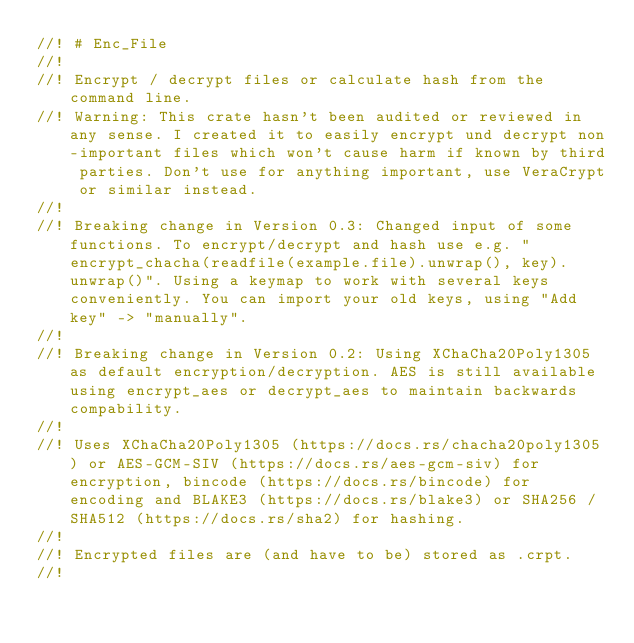Convert code to text. <code><loc_0><loc_0><loc_500><loc_500><_Rust_>//! # Enc_File
//!
//! Encrypt / decrypt files or calculate hash from the command line.
//! Warning: This crate hasn't been audited or reviewed in any sense. I created it to easily encrypt und decrypt non-important files which won't cause harm if known by third parties. Don't use for anything important, use VeraCrypt or similar instead.
//!
//! Breaking change in Version 0.3: Changed input of some functions. To encrypt/decrypt and hash use e.g. "encrypt_chacha(readfile(example.file).unwrap(), key).unwrap()". Using a keymap to work with several keys conveniently. You can import your old keys, using "Add key" -> "manually".
//!
//! Breaking change in Version 0.2: Using XChaCha20Poly1305 as default encryption/decryption. AES is still available using encrypt_aes or decrypt_aes to maintain backwards compability.
//!
//! Uses XChaCha20Poly1305 (https://docs.rs/chacha20poly1305) or AES-GCM-SIV (https://docs.rs/aes-gcm-siv) for encryption, bincode (https://docs.rs/bincode) for encoding and BLAKE3 (https://docs.rs/blake3) or SHA256 / SHA512 (https://docs.rs/sha2) for hashing.
//!
//! Encrypted files are (and have to be) stored as .crpt.
//!</code> 